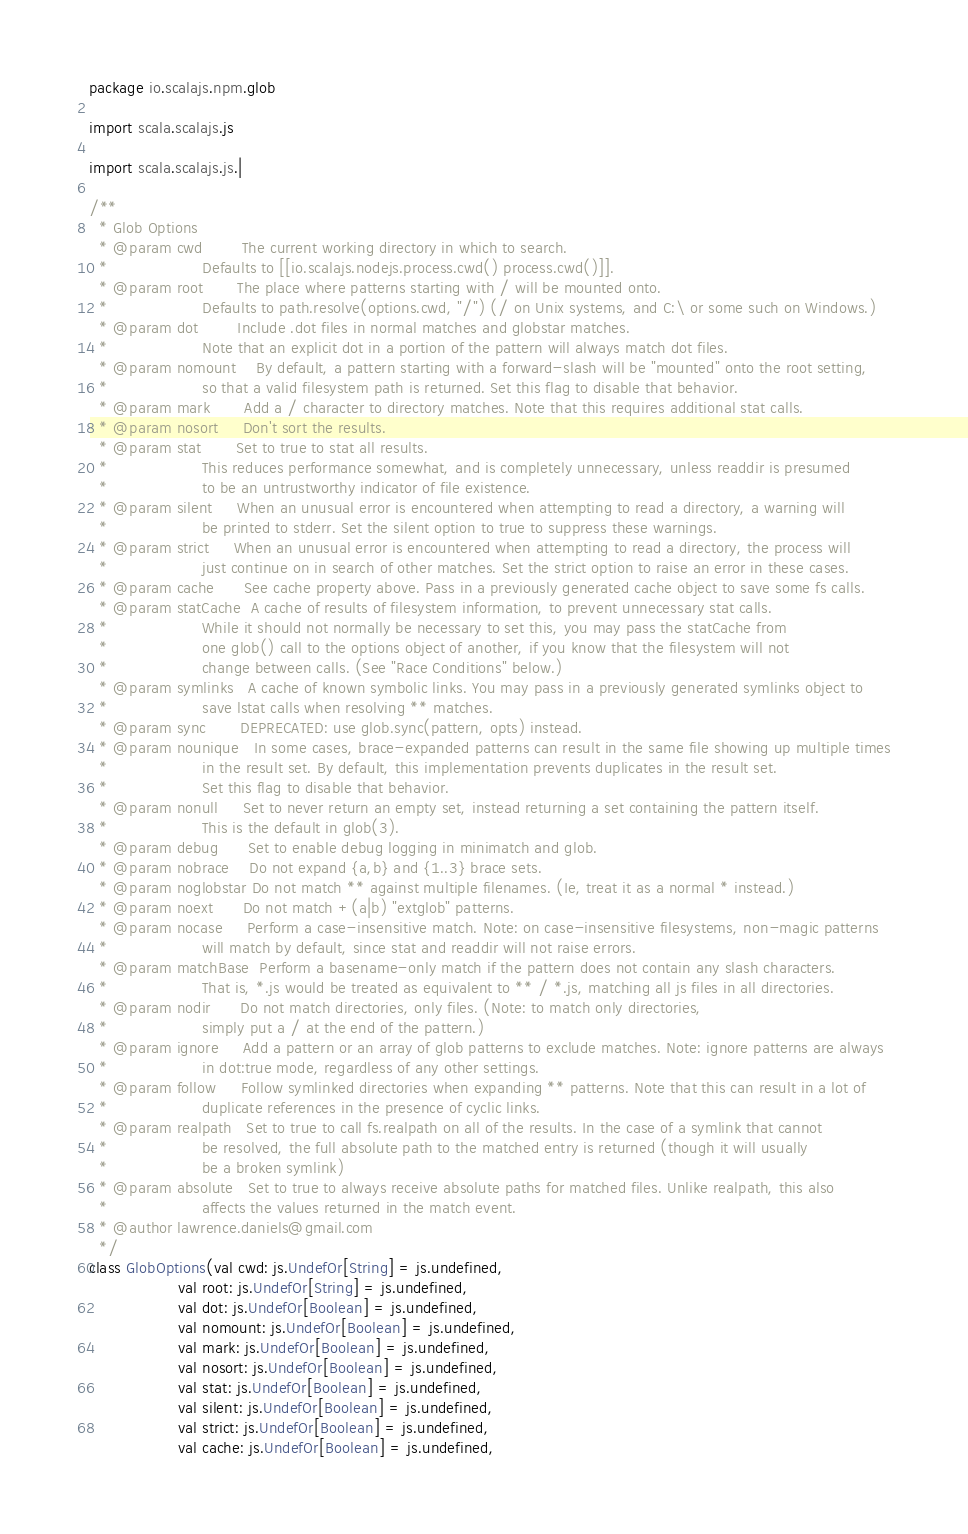<code> <loc_0><loc_0><loc_500><loc_500><_Scala_>package io.scalajs.npm.glob

import scala.scalajs.js

import scala.scalajs.js.|

/**
  * Glob Options
  * @param cwd        The current working directory in which to search.
  *                   Defaults to [[io.scalajs.nodejs.process.cwd() process.cwd()]].
  * @param root       The place where patterns starting with / will be mounted onto.
  *                   Defaults to path.resolve(options.cwd, "/") (/ on Unix systems, and C:\ or some such on Windows.)
  * @param dot        Include .dot files in normal matches and globstar matches.
  *                   Note that an explicit dot in a portion of the pattern will always match dot files.
  * @param nomount    By default, a pattern starting with a forward-slash will be "mounted" onto the root setting,
  *                   so that a valid filesystem path is returned. Set this flag to disable that behavior.
  * @param mark       Add a / character to directory matches. Note that this requires additional stat calls.
  * @param nosort     Don't sort the results.
  * @param stat       Set to true to stat all results.
  *                   This reduces performance somewhat, and is completely unnecessary, unless readdir is presumed
  *                   to be an untrustworthy indicator of file existence.
  * @param silent     When an unusual error is encountered when attempting to read a directory, a warning will
  *                   be printed to stderr. Set the silent option to true to suppress these warnings.
  * @param strict     When an unusual error is encountered when attempting to read a directory, the process will
  *                   just continue on in search of other matches. Set the strict option to raise an error in these cases.
  * @param cache      See cache property above. Pass in a previously generated cache object to save some fs calls.
  * @param statCache  A cache of results of filesystem information, to prevent unnecessary stat calls.
  *                   While it should not normally be necessary to set this, you may pass the statCache from
  *                   one glob() call to the options object of another, if you know that the filesystem will not
  *                   change between calls. (See "Race Conditions" below.)
  * @param symlinks   A cache of known symbolic links. You may pass in a previously generated symlinks object to
  *                   save lstat calls when resolving ** matches.
  * @param sync       DEPRECATED: use glob.sync(pattern, opts) instead.
  * @param nounique   In some cases, brace-expanded patterns can result in the same file showing up multiple times
  *                   in the result set. By default, this implementation prevents duplicates in the result set.
  *                   Set this flag to disable that behavior.
  * @param nonull     Set to never return an empty set, instead returning a set containing the pattern itself.
  *                   This is the default in glob(3).
  * @param debug      Set to enable debug logging in minimatch and glob.
  * @param nobrace    Do not expand {a,b} and {1..3} brace sets.
  * @param noglobstar Do not match ** against multiple filenames. (Ie, treat it as a normal * instead.)
  * @param noext      Do not match +(a|b) "extglob" patterns.
  * @param nocase     Perform a case-insensitive match. Note: on case-insensitive filesystems, non-magic patterns
  *                   will match by default, since stat and readdir will not raise errors.
  * @param matchBase  Perform a basename-only match if the pattern does not contain any slash characters.
  *                   That is, *.js would be treated as equivalent to ** / *.js, matching all js files in all directories.
  * @param nodir      Do not match directories, only files. (Note: to match only directories,
  *                   simply put a / at the end of the pattern.)
  * @param ignore     Add a pattern or an array of glob patterns to exclude matches. Note: ignore patterns are always
  *                   in dot:true mode, regardless of any other settings.
  * @param follow     Follow symlinked directories when expanding ** patterns. Note that this can result in a lot of
  *                   duplicate references in the presence of cyclic links.
  * @param realpath   Set to true to call fs.realpath on all of the results. In the case of a symlink that cannot
  *                   be resolved, the full absolute path to the matched entry is returned (though it will usually
  *                   be a broken symlink)
  * @param absolute   Set to true to always receive absolute paths for matched files. Unlike realpath, this also
  *                   affects the values returned in the match event.
  * @author lawrence.daniels@gmail.com
  */
class GlobOptions(val cwd: js.UndefOr[String] = js.undefined,
                  val root: js.UndefOr[String] = js.undefined,
                  val dot: js.UndefOr[Boolean] = js.undefined,
                  val nomount: js.UndefOr[Boolean] = js.undefined,
                  val mark: js.UndefOr[Boolean] = js.undefined,
                  val nosort: js.UndefOr[Boolean] = js.undefined,
                  val stat: js.UndefOr[Boolean] = js.undefined,
                  val silent: js.UndefOr[Boolean] = js.undefined,
                  val strict: js.UndefOr[Boolean] = js.undefined,
                  val cache: js.UndefOr[Boolean] = js.undefined,</code> 